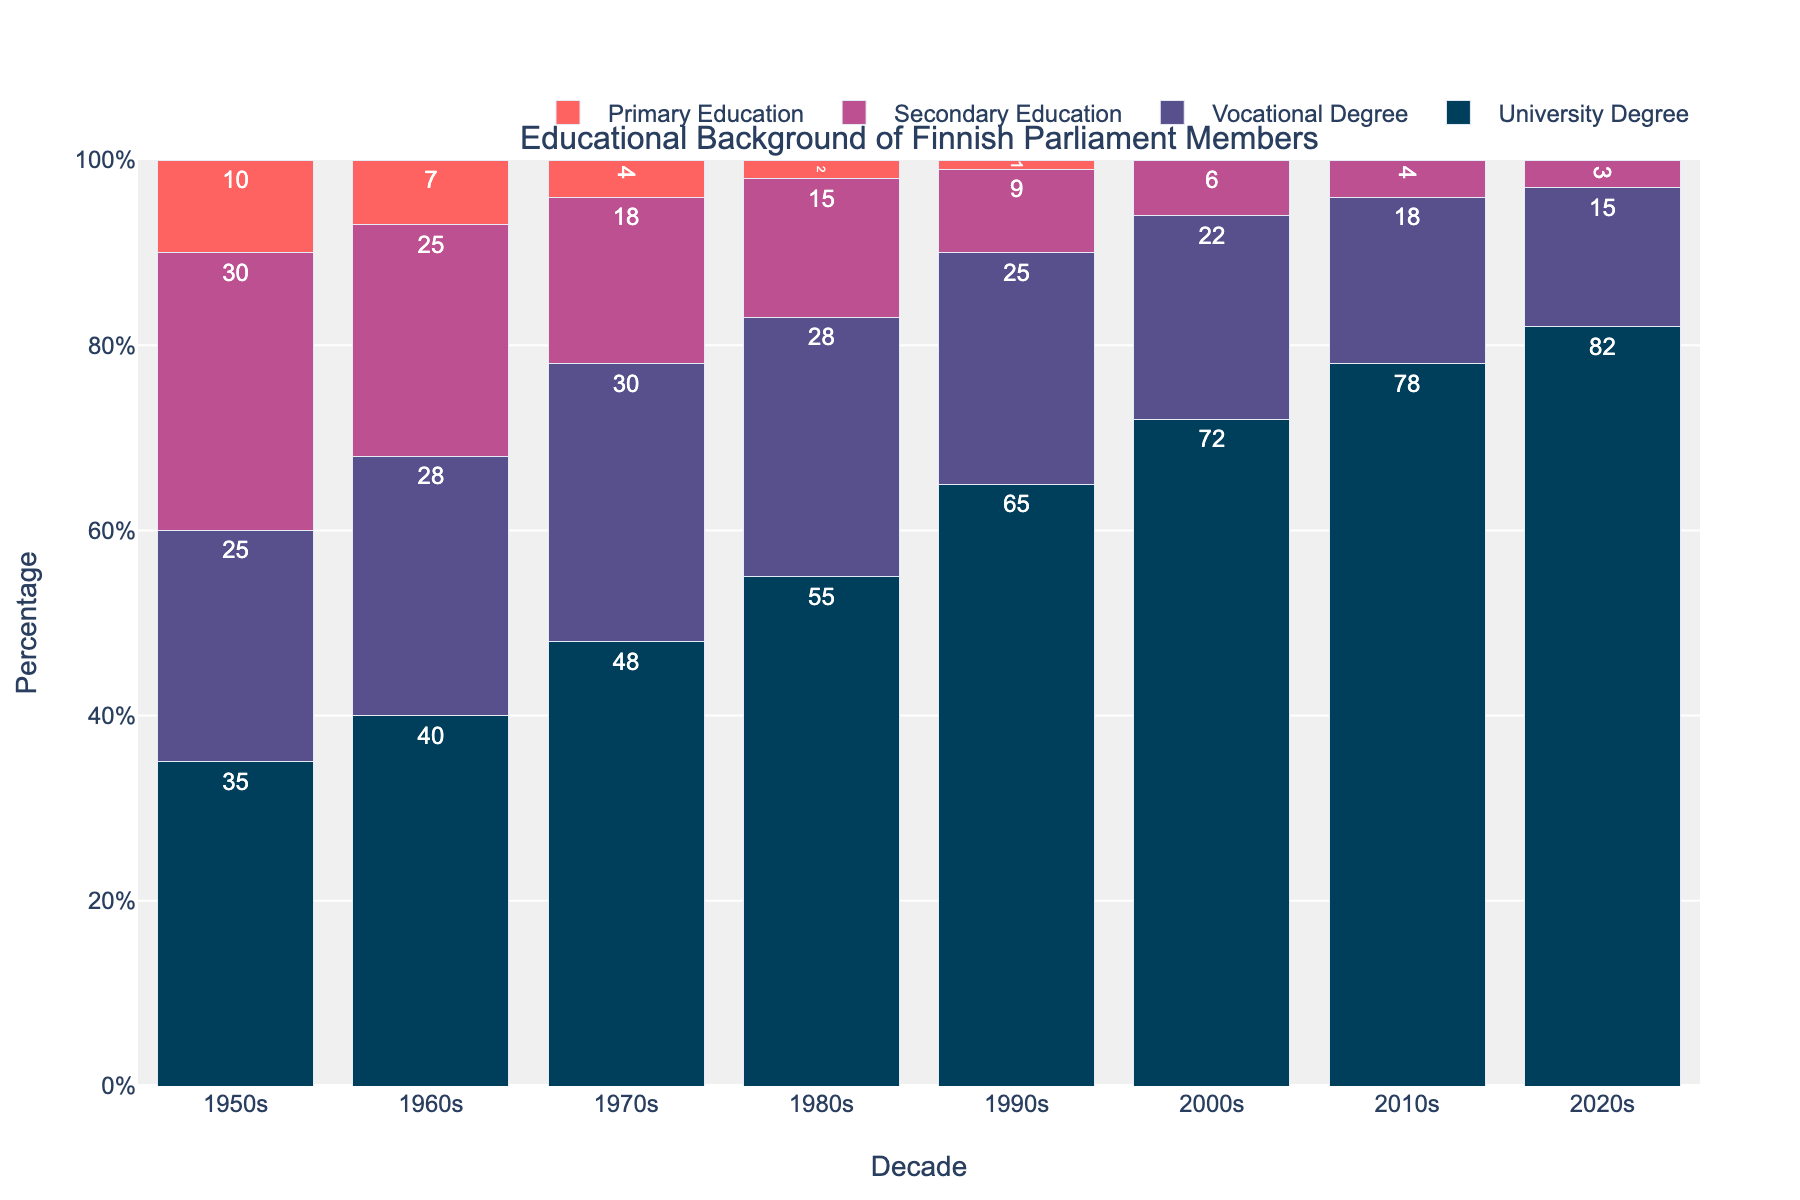What trend is observed in the percentage of Finnish parliament members with University Degrees from the 1950s to the 2020s? Observe the increasing heights of the bars representing University Degrees from the 1950s to the 2020s. The bars consistently grow taller each decade, indicating a rising trend.
Answer: Increasing How does the number of parliament members with Vocational Degrees in the 2000s compare to those in the 1970s? Compare the height of the bars for Vocational Degrees in the 2000s (22) to those in the 1970s (30). The bar in the 2000s is shorter.
Answer: Decreased What is the difference in the percentage of parliament members with Primary Education between the 1950s and 1970s? Subtract the percentage in the 1970s (4) from the percentage in the 1950s (10). 10 - 4 = 6.
Answer: 6 Which decade had the lowest percentage of parliament members with Secondary Education? Look for the shortest bar in the Secondary Education category, which is in the 2020s with a height of 3%.
Answer: 2020s What percentage of parliament members had University Degrees in the 1990s and how does this compare to the 2010s? Note the percentages for University Degrees in the 1990s (65%) and 2010s (78%). The difference is 78% - 65% = 13%.
Answer: 13% Which category experienced the most consistent decline from the 1950s to the 2020s? Compare the downward trends for all categories. Primary Education and Secondary Education both decline, but Primary Education reaches zero quickest, showing a more consistent decline.
Answer: Primary Education How do the educational levels in the 1960s compare visually to the 1980s? Look at the bars for both decades. The 1960s have shorter bars in all categories compared to the 1980s, particularly in University Degrees which show a substantial increase.
Answer: Educational levels increased What is the total percentage of parliament members with either Secondary or Primary Education in the 1970s? Add the percentages of Secondary Education (18) and Primary Education (4) for the 1970s. 18 + 4 = 22.
Answer: 22% Was there any decade where the percentage of parliament members with Vocational Degrees increased? Compare the bars for Vocational Degrees across all decades. The bar grows from 25% in the 1950s to 28% in the 1960s and 30% in the 1970s.
Answer: Yes Which category had the biggest increase in percentage from the 1950s to the 2020s? Compare the starting and ending heights for all categories. University Degrees increase from 35% to 82%, a difference of 47%, which is the largest compared to other categories.
Answer: University Degrees 